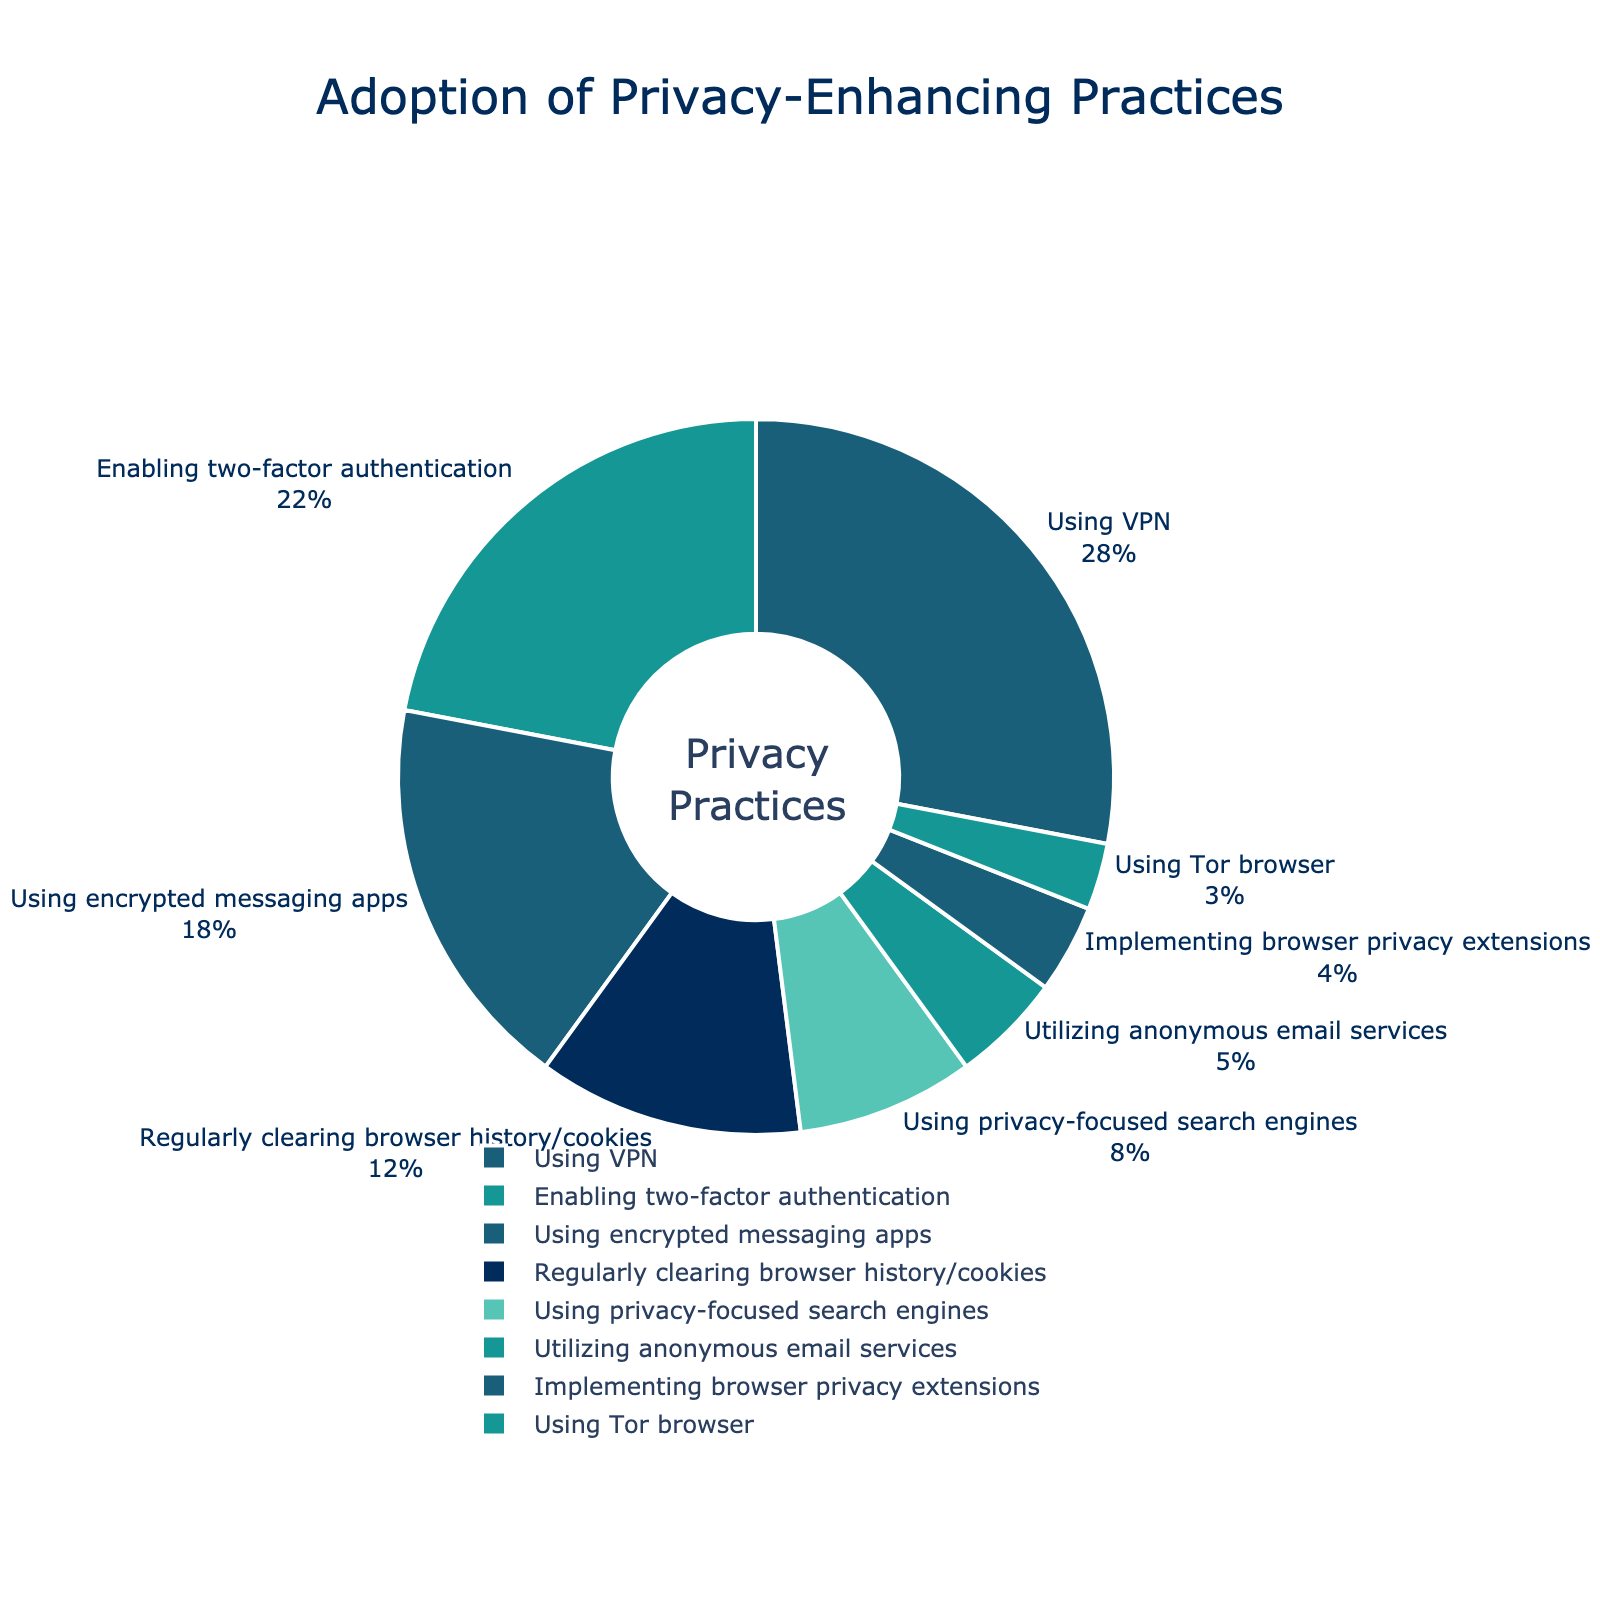What percentage of users adopt VPNs as a privacy-enhancing practice? Look at the segment labeled "Using VPN" in the pie chart. The percentage is directly displayed.
Answer: 28% Compare the percentage of users enabling two-factor authentication to those using encrypted messaging apps. Find the segments labeled "Enabling two-factor authentication" and "Using encrypted messaging apps." Compare their percentages: 22% for two-factor authentication and 18% for encrypted messaging apps.
Answer: Two-factor authentication: 22%, Encrypted messaging apps: 18% Which privacy-enhancing practice is the least adopted? Identify the segment with the smallest percentage. The "Using Tor browser" segment is the smallest, showing 3%.
Answer: Using Tor browser with 3% What is the combined percentage of users who regularly clear their browser history/cookies and those using privacy-focused search engines? Add the percentages of "Regularly clearing browser history/cookies" (12%) and "Using privacy-focused search engines" (8%).
Answer: 20% How does the percentage of users utilizing anonymous email services compare to those implementing browser privacy extensions? Compare the segments labeled "Utilizing anonymous email services" (5%) and "Implementing browser privacy extensions" (4%).
Answer: Anonymous email services: 5%, Browser privacy extensions: 4% What is the most adopted privacy-enhancing practice? Identify the segment with the highest percentage. The "Using VPN" segment shows 28%, which is the highest.
Answer: Using VPN with 28% Which three privacy-enhancing practices are adopted by a similar percentage of users? Identify segments with close percentages. "Using VPN" (28%), "Enabling two-factor authentication" (22%), and "Using encrypted messaging apps" (18%) have relatively close percentages.
Answer: Using VPN, Enabling two-factor authentication, Using encrypted messaging apps Calculate the percentage difference between users who enable two-factor authentication and those who use privacy-focused search engines. Subtract the percentage of "Using privacy-focused search engines" (8%) from "Enabling two-factor authentication" (22%). The difference is 22% - 8% = 14%.
Answer: 14% Which practice falls exactly in the middle percentage-wise when ordered from highest to lowest adoption? Arrange the practices: Using VPN (28%), Enabling two-factor authentication (22%), Using encrypted messaging apps (18%), Regularly clearing browser history/cookies (12%), Using privacy-focused search engines (8%), Utilizing anonymous email services (5%), Implementing browser privacy extensions (4%), Using Tor browser (3%). The middle practice is "Regularly clearing browser history/cookies" (12%).
Answer: Regularly clearing browser history/cookies 